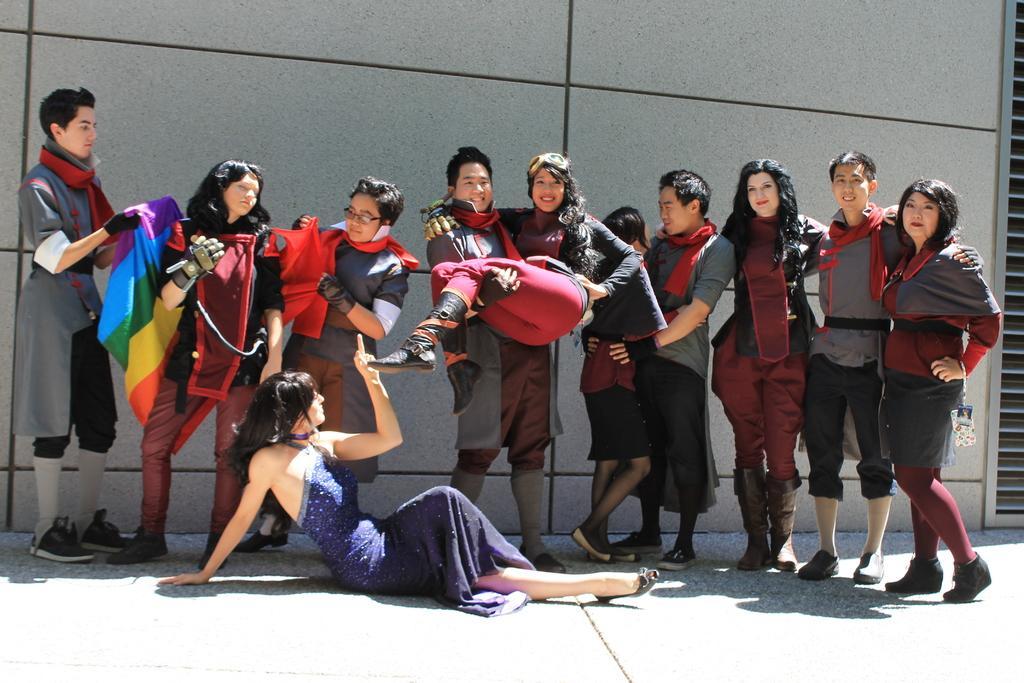How would you summarize this image in a sentence or two? As we can see in the image there are group of people and building. The man on the left side is holding a cloth. 